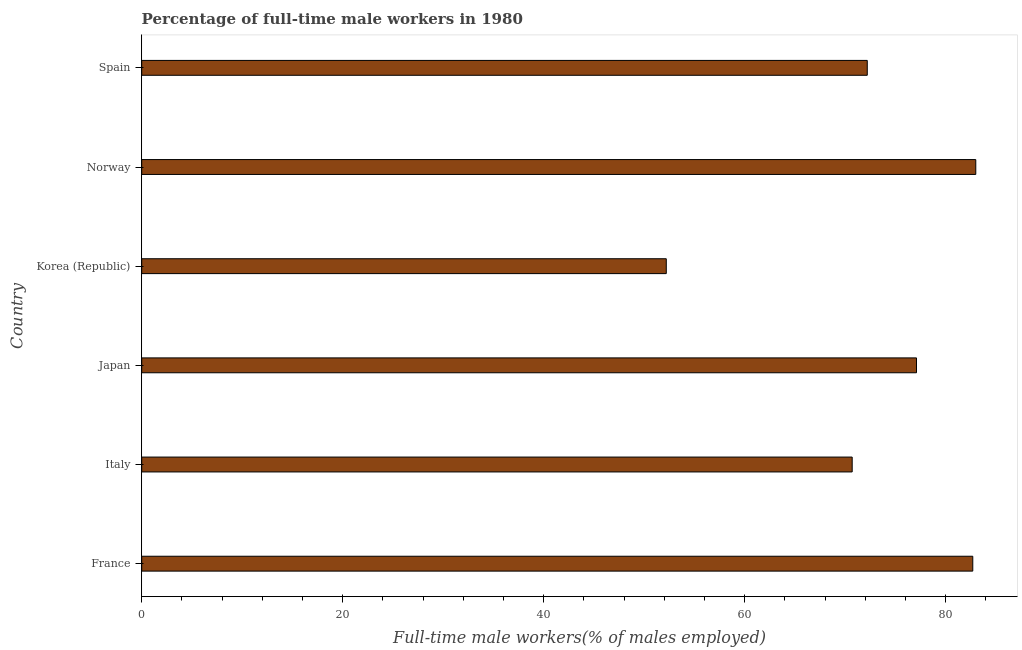Does the graph contain any zero values?
Your response must be concise. No. Does the graph contain grids?
Ensure brevity in your answer.  No. What is the title of the graph?
Your response must be concise. Percentage of full-time male workers in 1980. What is the label or title of the X-axis?
Your answer should be very brief. Full-time male workers(% of males employed). What is the label or title of the Y-axis?
Your response must be concise. Country. What is the percentage of full-time male workers in Japan?
Your response must be concise. 77.1. Across all countries, what is the minimum percentage of full-time male workers?
Your response must be concise. 52.2. What is the sum of the percentage of full-time male workers?
Provide a succinct answer. 437.9. What is the difference between the percentage of full-time male workers in Korea (Republic) and Spain?
Offer a very short reply. -20. What is the average percentage of full-time male workers per country?
Provide a short and direct response. 72.98. What is the median percentage of full-time male workers?
Keep it short and to the point. 74.65. What is the ratio of the percentage of full-time male workers in France to that in Italy?
Keep it short and to the point. 1.17. Is the percentage of full-time male workers in Italy less than that in Korea (Republic)?
Your answer should be compact. No. Is the sum of the percentage of full-time male workers in Italy and Japan greater than the maximum percentage of full-time male workers across all countries?
Ensure brevity in your answer.  Yes. What is the difference between the highest and the lowest percentage of full-time male workers?
Ensure brevity in your answer.  30.8. In how many countries, is the percentage of full-time male workers greater than the average percentage of full-time male workers taken over all countries?
Your answer should be very brief. 3. How many bars are there?
Give a very brief answer. 6. What is the difference between two consecutive major ticks on the X-axis?
Ensure brevity in your answer.  20. Are the values on the major ticks of X-axis written in scientific E-notation?
Your answer should be compact. No. What is the Full-time male workers(% of males employed) of France?
Offer a terse response. 82.7. What is the Full-time male workers(% of males employed) of Italy?
Offer a terse response. 70.7. What is the Full-time male workers(% of males employed) in Japan?
Provide a succinct answer. 77.1. What is the Full-time male workers(% of males employed) of Korea (Republic)?
Keep it short and to the point. 52.2. What is the Full-time male workers(% of males employed) in Norway?
Offer a very short reply. 83. What is the Full-time male workers(% of males employed) of Spain?
Ensure brevity in your answer.  72.2. What is the difference between the Full-time male workers(% of males employed) in France and Italy?
Ensure brevity in your answer.  12. What is the difference between the Full-time male workers(% of males employed) in France and Korea (Republic)?
Keep it short and to the point. 30.5. What is the difference between the Full-time male workers(% of males employed) in France and Norway?
Provide a short and direct response. -0.3. What is the difference between the Full-time male workers(% of males employed) in Italy and Japan?
Offer a terse response. -6.4. What is the difference between the Full-time male workers(% of males employed) in Italy and Korea (Republic)?
Give a very brief answer. 18.5. What is the difference between the Full-time male workers(% of males employed) in Italy and Norway?
Give a very brief answer. -12.3. What is the difference between the Full-time male workers(% of males employed) in Japan and Korea (Republic)?
Make the answer very short. 24.9. What is the difference between the Full-time male workers(% of males employed) in Korea (Republic) and Norway?
Give a very brief answer. -30.8. What is the difference between the Full-time male workers(% of males employed) in Norway and Spain?
Make the answer very short. 10.8. What is the ratio of the Full-time male workers(% of males employed) in France to that in Italy?
Your answer should be very brief. 1.17. What is the ratio of the Full-time male workers(% of males employed) in France to that in Japan?
Give a very brief answer. 1.07. What is the ratio of the Full-time male workers(% of males employed) in France to that in Korea (Republic)?
Offer a very short reply. 1.58. What is the ratio of the Full-time male workers(% of males employed) in France to that in Norway?
Ensure brevity in your answer.  1. What is the ratio of the Full-time male workers(% of males employed) in France to that in Spain?
Offer a terse response. 1.15. What is the ratio of the Full-time male workers(% of males employed) in Italy to that in Japan?
Your response must be concise. 0.92. What is the ratio of the Full-time male workers(% of males employed) in Italy to that in Korea (Republic)?
Offer a very short reply. 1.35. What is the ratio of the Full-time male workers(% of males employed) in Italy to that in Norway?
Keep it short and to the point. 0.85. What is the ratio of the Full-time male workers(% of males employed) in Japan to that in Korea (Republic)?
Your response must be concise. 1.48. What is the ratio of the Full-time male workers(% of males employed) in Japan to that in Norway?
Your answer should be compact. 0.93. What is the ratio of the Full-time male workers(% of males employed) in Japan to that in Spain?
Your response must be concise. 1.07. What is the ratio of the Full-time male workers(% of males employed) in Korea (Republic) to that in Norway?
Offer a very short reply. 0.63. What is the ratio of the Full-time male workers(% of males employed) in Korea (Republic) to that in Spain?
Provide a succinct answer. 0.72. What is the ratio of the Full-time male workers(% of males employed) in Norway to that in Spain?
Give a very brief answer. 1.15. 